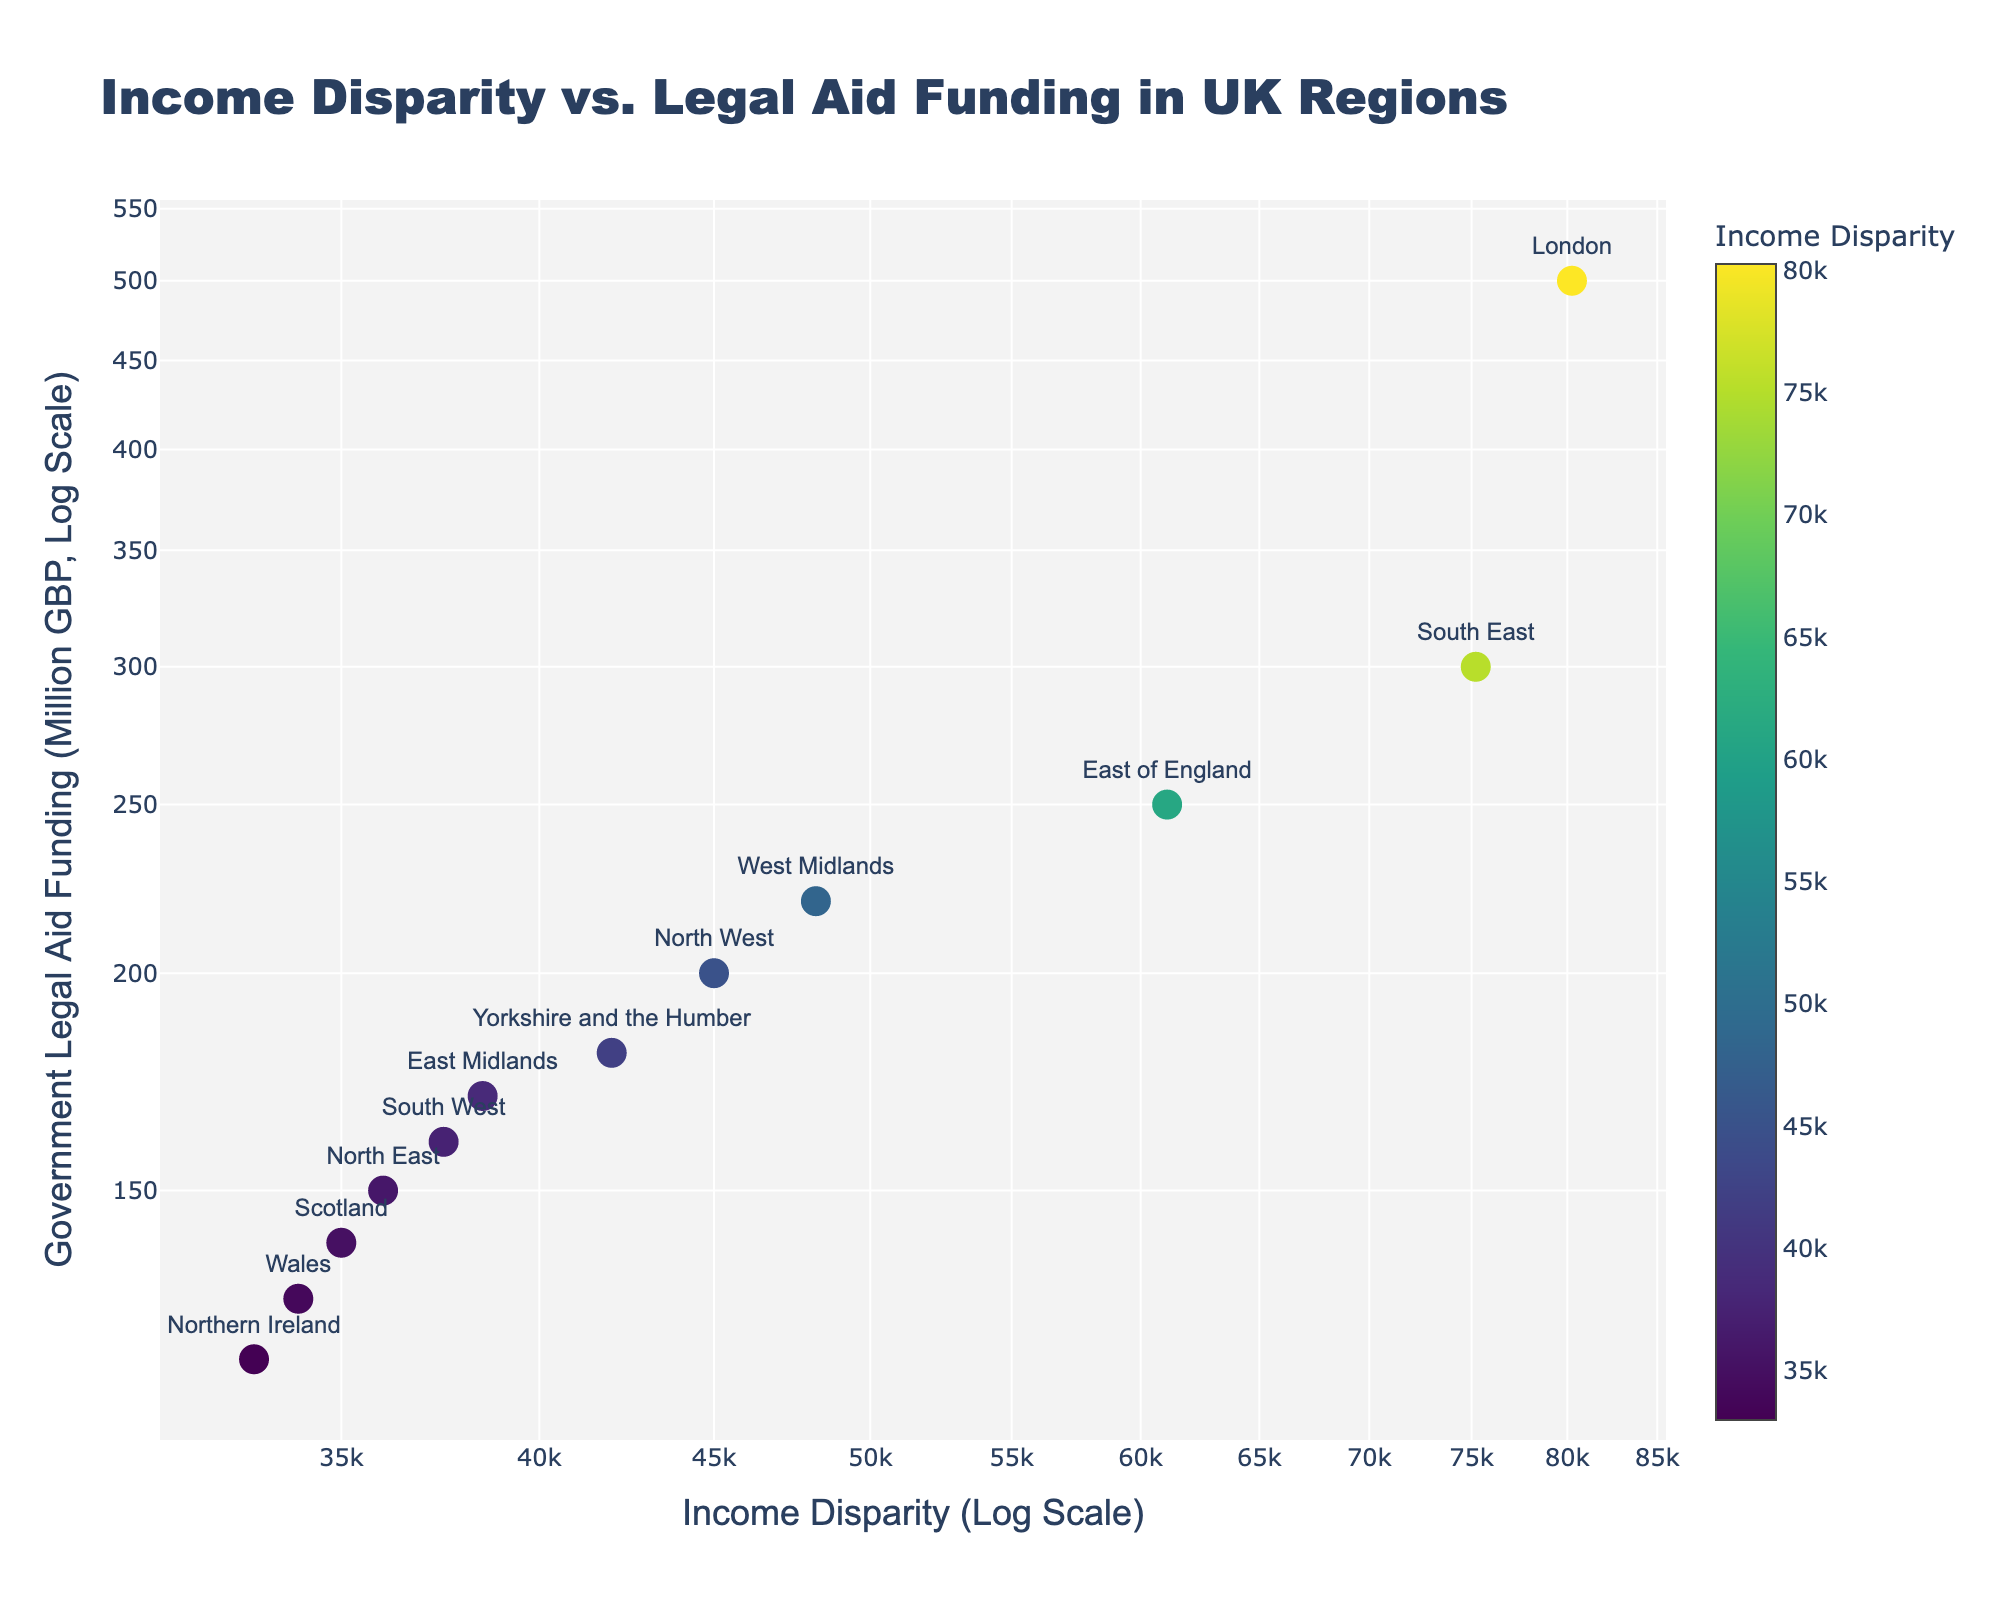what does the title of the plot indicate? The title of the plot is "Income Disparity vs. Legal Aid Funding in UK Regions." It explains that the scatter plot illustrates the relationship between income disparity and government legal aid funding across various regions in the UK.
Answer: Income Disparity vs. Legal Aid Funding in UK Regions how many data points are shown in the scatter plot? Each region has one data point, and there are 12 regions listed in the data. Therefore, there are 12 data points in the scatter plot.
Answer: 12 which region has the highest income disparity? By examining the placement of the data points on the log scale x-axis, the region with the highest income disparity is located furthest to the right. The text labels above the markers indicate that London has the highest income disparity.
Answer: London compare the legal aid funding between the London and South East regions. Which one is greater, and by how much? London has a government legal aid funding of 500 million GBP, and the South East has 300 million GBP. The difference in funding between London and the South East is 500 - 300 = 200 million GBP.
Answer: London by 200 million GBP what is the axis type used in the plot? Both the x-axis and y-axis are in log scale, as indicated by the labels "Income Disparity (Log Scale)" and "Government Legal Aid Funding (Million GBP, Log Scale)."
Answer: Log scale rank the regions based on their legal aid funding from highest to lowest. Observing the y-axis and the data points, the regions ranked from highest to lowest government legal aid funding are: London, South East, East of England, West Midlands, North West, Yorkshire and the Humber, East Midlands, South West, North East, Scotland, Wales, Northern Ireland.
Answer: London > South East > East of England > West Midlands > North West > Yorkshire and the Humber > East Midlands > South West > North East > Scotland > Wales > Northern Ireland what kind of color scale is used to indicate income disparity? The color scale used is a Viridis color scale, which transitions through a range of colors and is visually represented by the color bar to the right of the plot. The colors range from darker to lighter tones as income disparity increases.
Answer: Viridis how is the region information presented on the plot? The regions are labeled directly on the plot as text next to the respective data points. This helps in easily identifying which data point corresponds to which region.
Answer: As text labels next to data points which region has the second-lowest legal aid funding? By examining the y-axis and position of the data points, Northern Ireland has the lowest funding, and Wales, positioned just slightly above, has the second-lowest legal aid funding at 130 million GBP.
Answer: Wales 